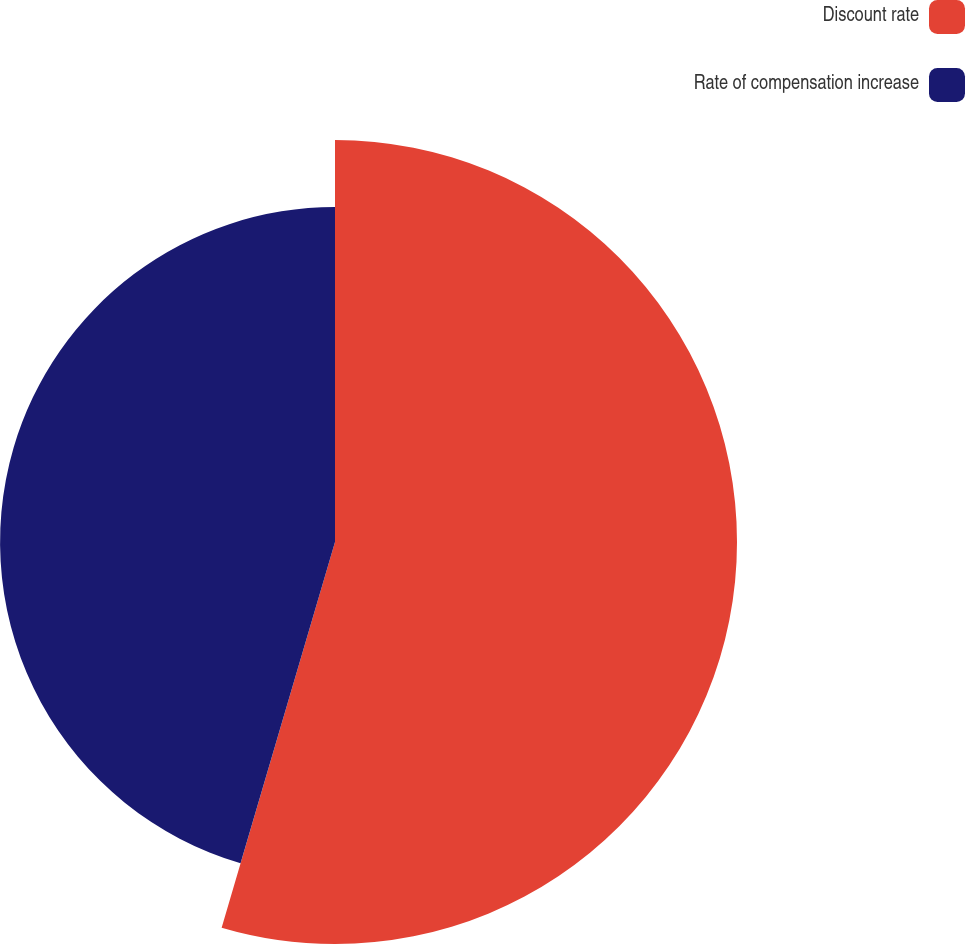Convert chart to OTSL. <chart><loc_0><loc_0><loc_500><loc_500><pie_chart><fcel>Discount rate<fcel>Rate of compensation increase<nl><fcel>54.55%<fcel>45.45%<nl></chart> 